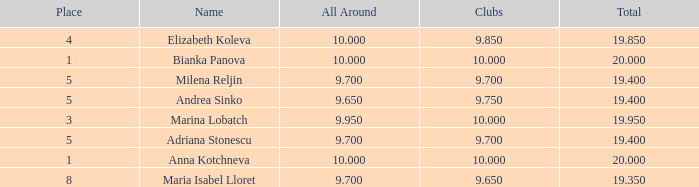65? None. 